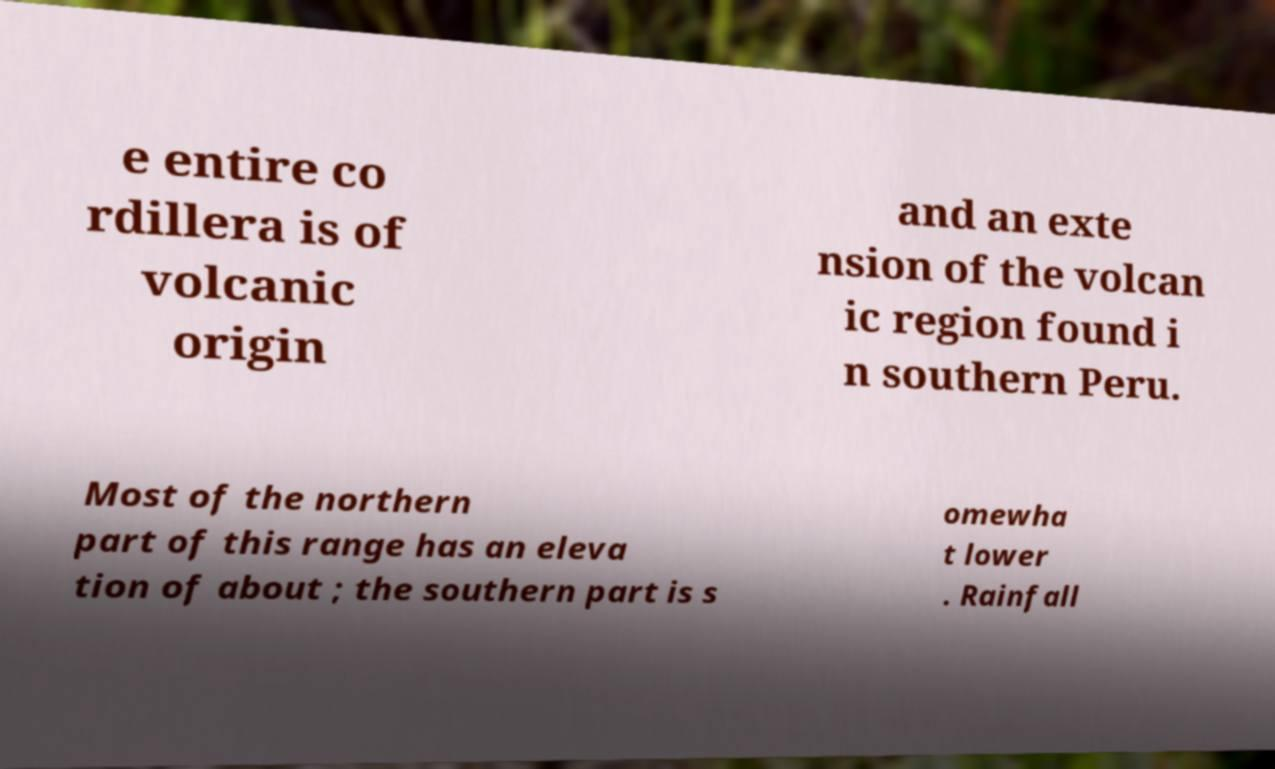Can you read and provide the text displayed in the image?This photo seems to have some interesting text. Can you extract and type it out for me? e entire co rdillera is of volcanic origin and an exte nsion of the volcan ic region found i n southern Peru. Most of the northern part of this range has an eleva tion of about ; the southern part is s omewha t lower . Rainfall 